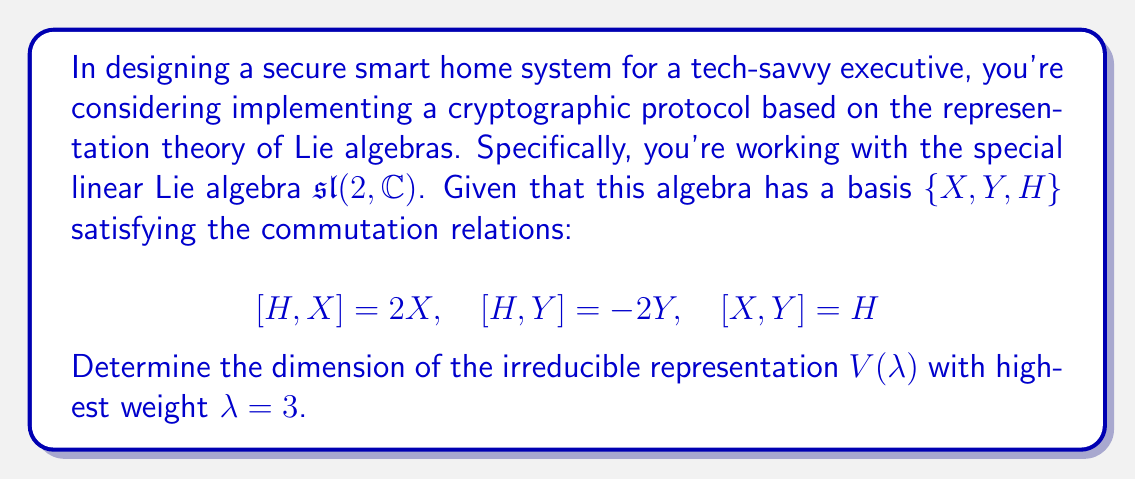Teach me how to tackle this problem. To solve this problem, we'll follow these steps:

1) In the representation theory of $\mathfrak{sl}(2, \mathbb{C})$, the irreducible representations are parameterized by non-negative integers $\lambda$, called the highest weight.

2) For a given highest weight $\lambda$, the corresponding irreducible representation $V(\lambda)$ has a basis of weight vectors $v_\lambda, v_{\lambda-2}, \ldots, v_{-\lambda+2}, v_{-\lambda}$.

3) The subscripts represent the eigenvalues of the action of $H$ on these vectors. They decrease by 2 each time, starting from $\lambda$ and ending at $-\lambda$.

4) The dimension of $V(\lambda)$ is equal to the number of these basis vectors, which is $\lambda + 1$.

5) In this case, we're given $\lambda = 3$. So, the basis vectors will be $v_3, v_1, v_{-1}, v_{-3}$.

6) Therefore, the dimension of $V(3)$ is $3 + 1 = 4$.

This representation could be used in the cryptographic system to encode messages or keys in a way that leverages the structure of the Lie algebra, potentially providing security benefits in the smart home system.
Answer: The dimension of the irreducible representation $V(\lambda)$ with highest weight $\lambda = 3$ is 4. 